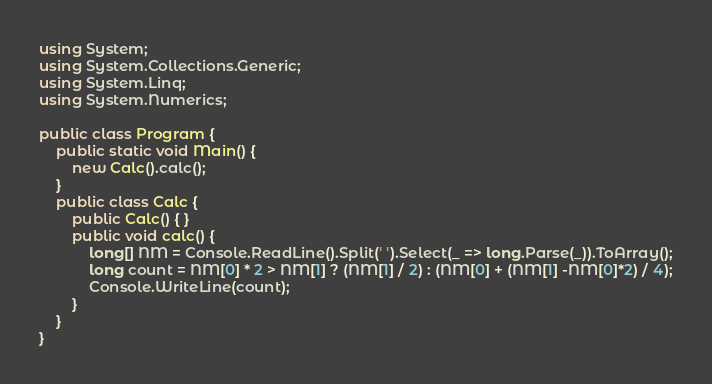Convert code to text. <code><loc_0><loc_0><loc_500><loc_500><_C#_>using System;
using System.Collections.Generic;
using System.Linq;
using System.Numerics;

public class Program {
	public static void Main() {
		new Calc().calc();
	}
	public class Calc {
		public Calc() { }
		public void calc() {
			long[] NM = Console.ReadLine().Split(' ').Select(_ => long.Parse(_)).ToArray();
			long count = NM[0] * 2 > NM[1] ? (NM[1] / 2) : (NM[0] + (NM[1] -NM[0]*2) / 4);
			Console.WriteLine(count);
		}
	}
}</code> 